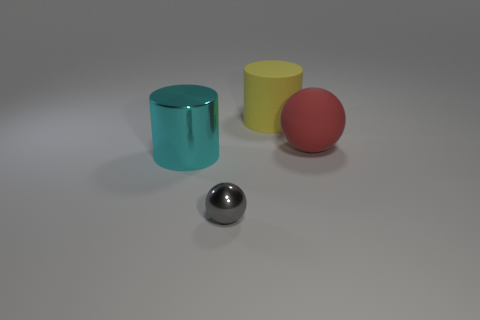What do you think the grey background represents? The grey background provides a neutral setting that doesn't compete for attention, allowing the objects in the foreground to stand out. In terms of symbolism, the grey expanse could represent a canvas of possibilities, a vast, undefined space where the objects might interact with each other without environmental distractions. 